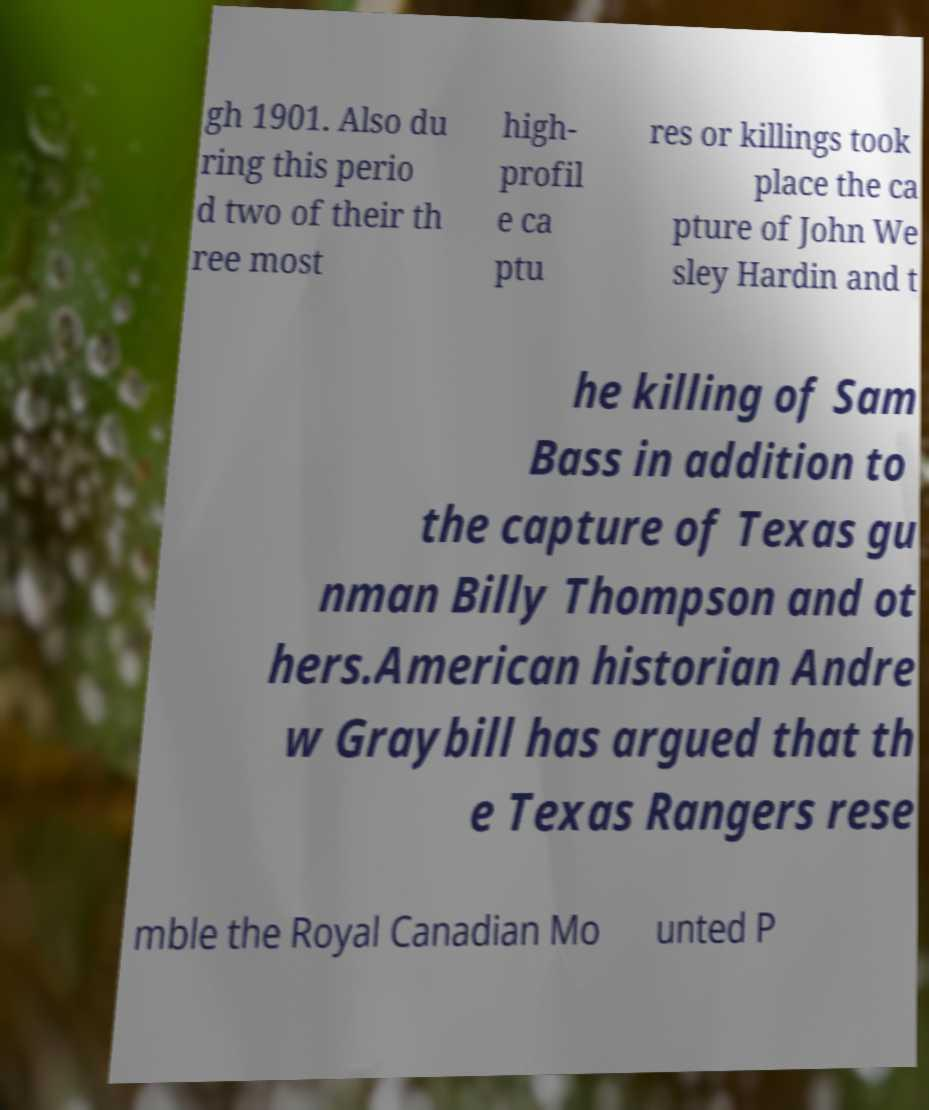Could you extract and type out the text from this image? gh 1901. Also du ring this perio d two of their th ree most high- profil e ca ptu res or killings took place the ca pture of John We sley Hardin and t he killing of Sam Bass in addition to the capture of Texas gu nman Billy Thompson and ot hers.American historian Andre w Graybill has argued that th e Texas Rangers rese mble the Royal Canadian Mo unted P 